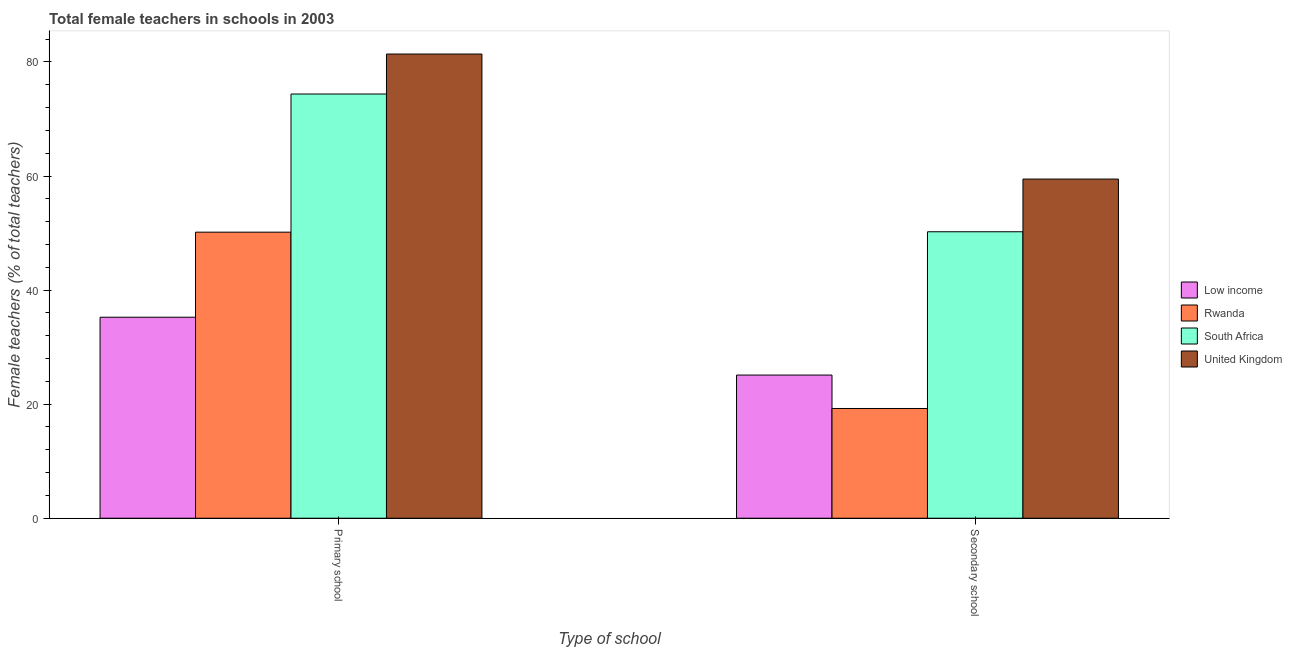How many groups of bars are there?
Ensure brevity in your answer.  2. How many bars are there on the 1st tick from the right?
Ensure brevity in your answer.  4. What is the label of the 2nd group of bars from the left?
Ensure brevity in your answer.  Secondary school. What is the percentage of female teachers in secondary schools in United Kingdom?
Give a very brief answer. 59.47. Across all countries, what is the maximum percentage of female teachers in primary schools?
Give a very brief answer. 81.39. Across all countries, what is the minimum percentage of female teachers in primary schools?
Your response must be concise. 35.24. In which country was the percentage of female teachers in primary schools maximum?
Your response must be concise. United Kingdom. What is the total percentage of female teachers in secondary schools in the graph?
Offer a very short reply. 154.04. What is the difference between the percentage of female teachers in primary schools in South Africa and that in United Kingdom?
Make the answer very short. -7.01. What is the difference between the percentage of female teachers in secondary schools in South Africa and the percentage of female teachers in primary schools in United Kingdom?
Keep it short and to the point. -31.16. What is the average percentage of female teachers in primary schools per country?
Provide a short and direct response. 60.29. What is the difference between the percentage of female teachers in primary schools and percentage of female teachers in secondary schools in South Africa?
Offer a very short reply. 24.15. In how many countries, is the percentage of female teachers in primary schools greater than 56 %?
Your answer should be compact. 2. What is the ratio of the percentage of female teachers in primary schools in United Kingdom to that in Rwanda?
Offer a very short reply. 1.62. Is the percentage of female teachers in secondary schools in Rwanda less than that in Low income?
Your response must be concise. Yes. In how many countries, is the percentage of female teachers in secondary schools greater than the average percentage of female teachers in secondary schools taken over all countries?
Make the answer very short. 2. What does the 1st bar from the left in Primary school represents?
Your answer should be compact. Low income. What does the 2nd bar from the right in Secondary school represents?
Your response must be concise. South Africa. Are all the bars in the graph horizontal?
Your answer should be compact. No. How many countries are there in the graph?
Ensure brevity in your answer.  4. What is the difference between two consecutive major ticks on the Y-axis?
Keep it short and to the point. 20. Does the graph contain any zero values?
Your answer should be very brief. No. Does the graph contain grids?
Offer a very short reply. No. Where does the legend appear in the graph?
Provide a short and direct response. Center right. What is the title of the graph?
Give a very brief answer. Total female teachers in schools in 2003. Does "Senegal" appear as one of the legend labels in the graph?
Provide a short and direct response. No. What is the label or title of the X-axis?
Make the answer very short. Type of school. What is the label or title of the Y-axis?
Provide a short and direct response. Female teachers (% of total teachers). What is the Female teachers (% of total teachers) of Low income in Primary school?
Your answer should be very brief. 35.24. What is the Female teachers (% of total teachers) of Rwanda in Primary school?
Offer a terse response. 50.16. What is the Female teachers (% of total teachers) of South Africa in Primary school?
Make the answer very short. 74.38. What is the Female teachers (% of total teachers) of United Kingdom in Primary school?
Ensure brevity in your answer.  81.39. What is the Female teachers (% of total teachers) in Low income in Secondary school?
Ensure brevity in your answer.  25.1. What is the Female teachers (% of total teachers) of Rwanda in Secondary school?
Keep it short and to the point. 19.24. What is the Female teachers (% of total teachers) of South Africa in Secondary school?
Offer a very short reply. 50.23. What is the Female teachers (% of total teachers) of United Kingdom in Secondary school?
Your answer should be very brief. 59.47. Across all Type of school, what is the maximum Female teachers (% of total teachers) of Low income?
Your answer should be compact. 35.24. Across all Type of school, what is the maximum Female teachers (% of total teachers) in Rwanda?
Keep it short and to the point. 50.16. Across all Type of school, what is the maximum Female teachers (% of total teachers) of South Africa?
Your answer should be compact. 74.38. Across all Type of school, what is the maximum Female teachers (% of total teachers) of United Kingdom?
Offer a very short reply. 81.39. Across all Type of school, what is the minimum Female teachers (% of total teachers) of Low income?
Offer a terse response. 25.1. Across all Type of school, what is the minimum Female teachers (% of total teachers) in Rwanda?
Your answer should be very brief. 19.24. Across all Type of school, what is the minimum Female teachers (% of total teachers) in South Africa?
Your response must be concise. 50.23. Across all Type of school, what is the minimum Female teachers (% of total teachers) of United Kingdom?
Offer a very short reply. 59.47. What is the total Female teachers (% of total teachers) of Low income in the graph?
Ensure brevity in your answer.  60.35. What is the total Female teachers (% of total teachers) in Rwanda in the graph?
Your response must be concise. 69.4. What is the total Female teachers (% of total teachers) of South Africa in the graph?
Provide a succinct answer. 124.61. What is the total Female teachers (% of total teachers) in United Kingdom in the graph?
Provide a succinct answer. 140.86. What is the difference between the Female teachers (% of total teachers) of Low income in Primary school and that in Secondary school?
Make the answer very short. 10.14. What is the difference between the Female teachers (% of total teachers) of Rwanda in Primary school and that in Secondary school?
Ensure brevity in your answer.  30.92. What is the difference between the Female teachers (% of total teachers) of South Africa in Primary school and that in Secondary school?
Offer a very short reply. 24.15. What is the difference between the Female teachers (% of total teachers) in United Kingdom in Primary school and that in Secondary school?
Your answer should be compact. 21.92. What is the difference between the Female teachers (% of total teachers) in Low income in Primary school and the Female teachers (% of total teachers) in Rwanda in Secondary school?
Your answer should be very brief. 16. What is the difference between the Female teachers (% of total teachers) of Low income in Primary school and the Female teachers (% of total teachers) of South Africa in Secondary school?
Your response must be concise. -14.99. What is the difference between the Female teachers (% of total teachers) in Low income in Primary school and the Female teachers (% of total teachers) in United Kingdom in Secondary school?
Offer a terse response. -24.23. What is the difference between the Female teachers (% of total teachers) in Rwanda in Primary school and the Female teachers (% of total teachers) in South Africa in Secondary school?
Provide a short and direct response. -0.07. What is the difference between the Female teachers (% of total teachers) in Rwanda in Primary school and the Female teachers (% of total teachers) in United Kingdom in Secondary school?
Give a very brief answer. -9.31. What is the difference between the Female teachers (% of total teachers) of South Africa in Primary school and the Female teachers (% of total teachers) of United Kingdom in Secondary school?
Your answer should be very brief. 14.91. What is the average Female teachers (% of total teachers) in Low income per Type of school?
Provide a succinct answer. 30.17. What is the average Female teachers (% of total teachers) in Rwanda per Type of school?
Offer a very short reply. 34.7. What is the average Female teachers (% of total teachers) of South Africa per Type of school?
Make the answer very short. 62.3. What is the average Female teachers (% of total teachers) of United Kingdom per Type of school?
Give a very brief answer. 70.43. What is the difference between the Female teachers (% of total teachers) in Low income and Female teachers (% of total teachers) in Rwanda in Primary school?
Your answer should be very brief. -14.92. What is the difference between the Female teachers (% of total teachers) in Low income and Female teachers (% of total teachers) in South Africa in Primary school?
Provide a short and direct response. -39.14. What is the difference between the Female teachers (% of total teachers) of Low income and Female teachers (% of total teachers) of United Kingdom in Primary school?
Ensure brevity in your answer.  -46.15. What is the difference between the Female teachers (% of total teachers) in Rwanda and Female teachers (% of total teachers) in South Africa in Primary school?
Your answer should be compact. -24.22. What is the difference between the Female teachers (% of total teachers) of Rwanda and Female teachers (% of total teachers) of United Kingdom in Primary school?
Give a very brief answer. -31.23. What is the difference between the Female teachers (% of total teachers) in South Africa and Female teachers (% of total teachers) in United Kingdom in Primary school?
Keep it short and to the point. -7.01. What is the difference between the Female teachers (% of total teachers) of Low income and Female teachers (% of total teachers) of Rwanda in Secondary school?
Ensure brevity in your answer.  5.86. What is the difference between the Female teachers (% of total teachers) of Low income and Female teachers (% of total teachers) of South Africa in Secondary school?
Give a very brief answer. -25.12. What is the difference between the Female teachers (% of total teachers) in Low income and Female teachers (% of total teachers) in United Kingdom in Secondary school?
Give a very brief answer. -34.36. What is the difference between the Female teachers (% of total teachers) in Rwanda and Female teachers (% of total teachers) in South Africa in Secondary school?
Provide a short and direct response. -30.99. What is the difference between the Female teachers (% of total teachers) in Rwanda and Female teachers (% of total teachers) in United Kingdom in Secondary school?
Give a very brief answer. -40.23. What is the difference between the Female teachers (% of total teachers) in South Africa and Female teachers (% of total teachers) in United Kingdom in Secondary school?
Provide a succinct answer. -9.24. What is the ratio of the Female teachers (% of total teachers) of Low income in Primary school to that in Secondary school?
Ensure brevity in your answer.  1.4. What is the ratio of the Female teachers (% of total teachers) in Rwanda in Primary school to that in Secondary school?
Provide a short and direct response. 2.61. What is the ratio of the Female teachers (% of total teachers) of South Africa in Primary school to that in Secondary school?
Provide a succinct answer. 1.48. What is the ratio of the Female teachers (% of total teachers) in United Kingdom in Primary school to that in Secondary school?
Offer a very short reply. 1.37. What is the difference between the highest and the second highest Female teachers (% of total teachers) in Low income?
Make the answer very short. 10.14. What is the difference between the highest and the second highest Female teachers (% of total teachers) in Rwanda?
Provide a short and direct response. 30.92. What is the difference between the highest and the second highest Female teachers (% of total teachers) in South Africa?
Keep it short and to the point. 24.15. What is the difference between the highest and the second highest Female teachers (% of total teachers) in United Kingdom?
Make the answer very short. 21.92. What is the difference between the highest and the lowest Female teachers (% of total teachers) in Low income?
Your answer should be compact. 10.14. What is the difference between the highest and the lowest Female teachers (% of total teachers) in Rwanda?
Give a very brief answer. 30.92. What is the difference between the highest and the lowest Female teachers (% of total teachers) in South Africa?
Give a very brief answer. 24.15. What is the difference between the highest and the lowest Female teachers (% of total teachers) of United Kingdom?
Keep it short and to the point. 21.92. 